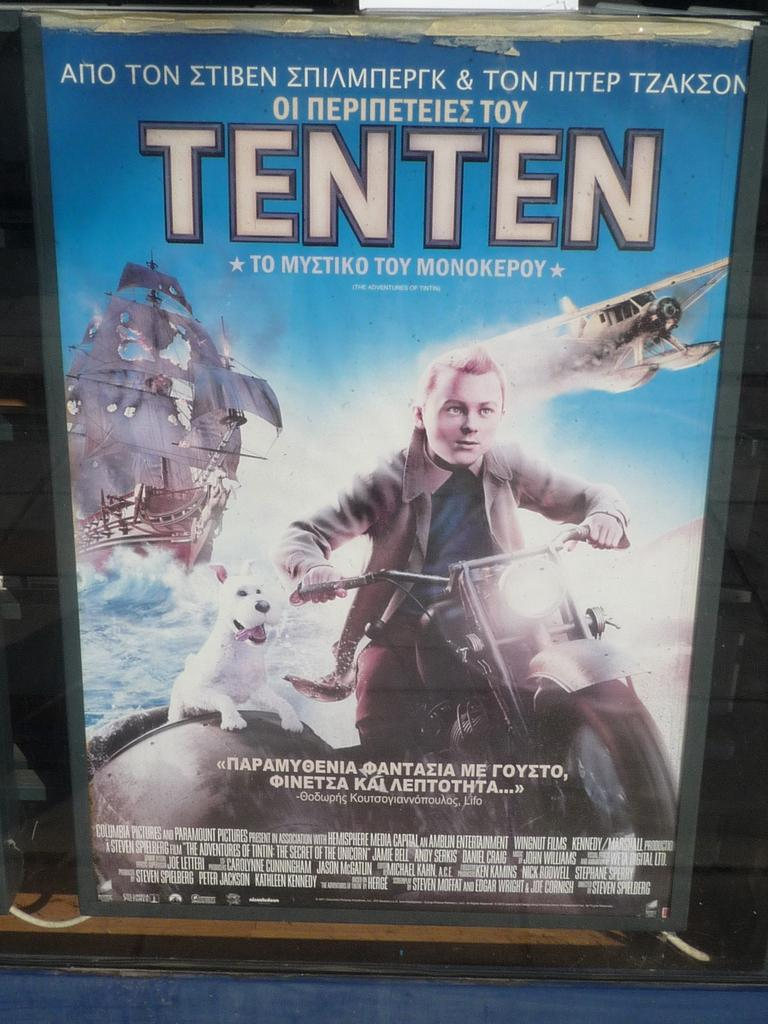What is the main subject of the image? The main subject of the image is a movie poster. Where is the movie poster located? The movie poster is on a display board. What elements are included on the movie poster? The movie poster contains pictures and text. What color is the balloon held by the mom in the image? There is no balloon or mom present in the image; it features a movie poster on a display board. 